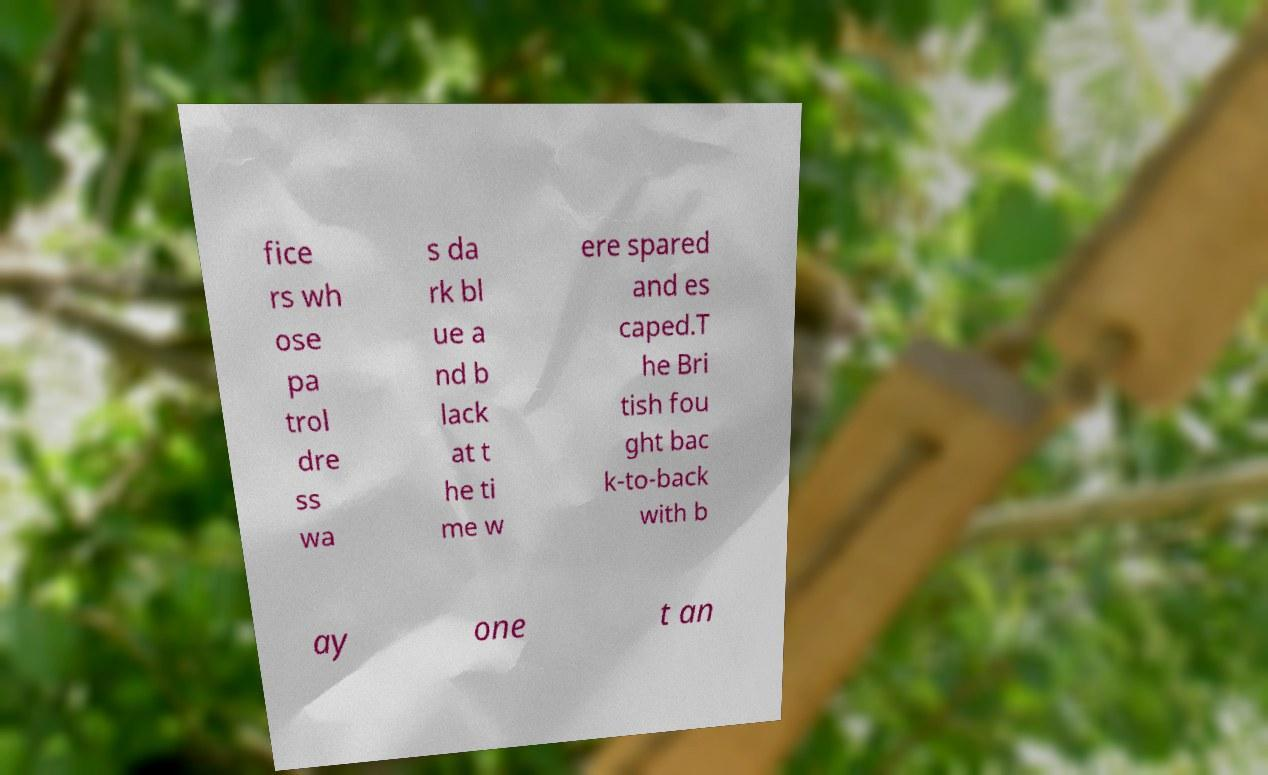Could you extract and type out the text from this image? fice rs wh ose pa trol dre ss wa s da rk bl ue a nd b lack at t he ti me w ere spared and es caped.T he Bri tish fou ght bac k-to-back with b ay one t an 